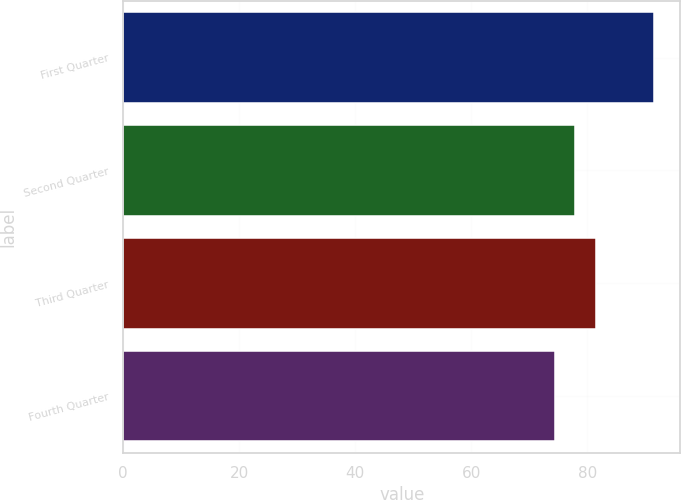Convert chart to OTSL. <chart><loc_0><loc_0><loc_500><loc_500><bar_chart><fcel>First Quarter<fcel>Second Quarter<fcel>Third Quarter<fcel>Fourth Quarter<nl><fcel>91.48<fcel>77.93<fcel>81.55<fcel>74.5<nl></chart> 